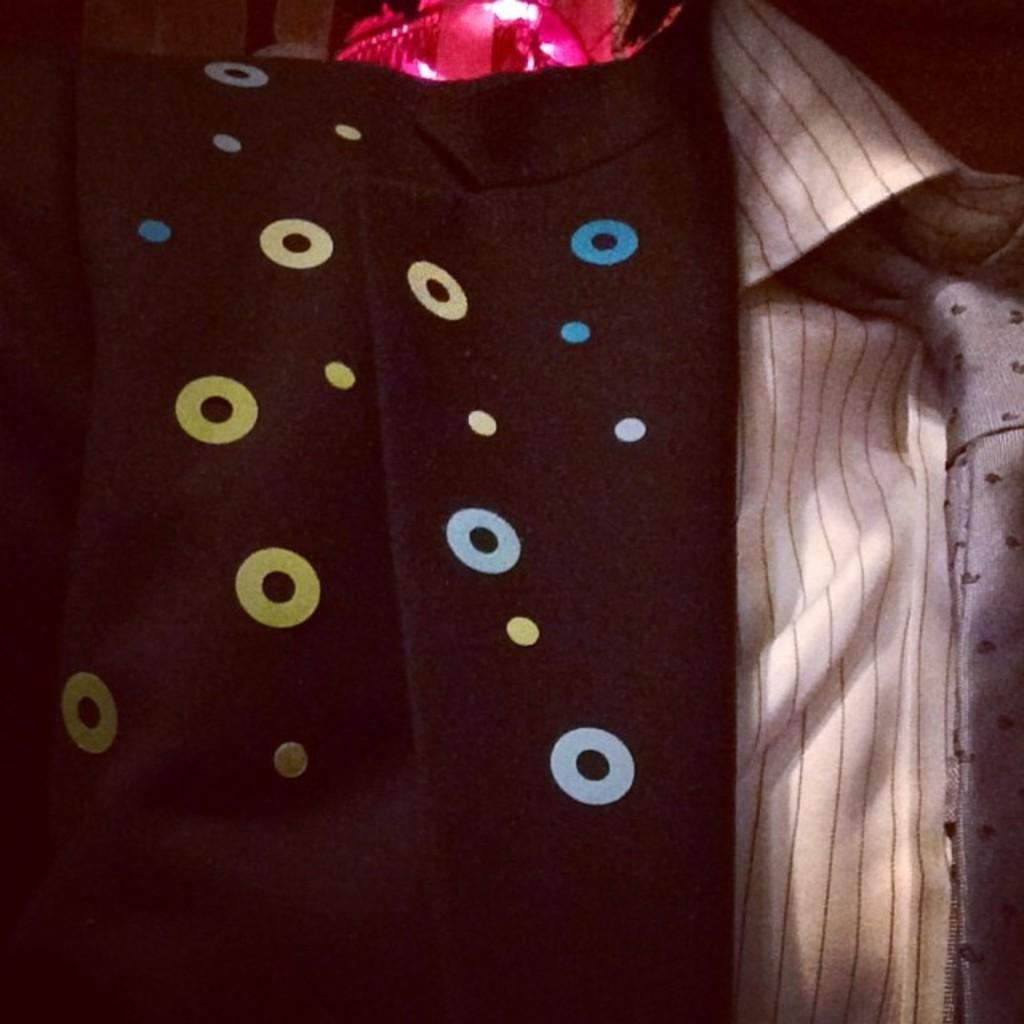What type of objects are in the image? There are clothes in the image. Can you describe the clothes in the image? The clothes are in different colors. Where is the nest of goldfish located in the image? There is no nest or goldfish present in the image; it features clothes in different colors. What month is depicted in the image? The image does not depict a specific month; it only shows clothes in different colors. 